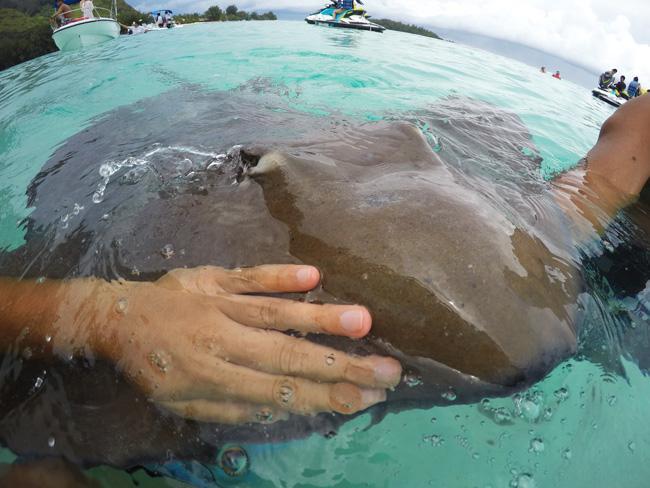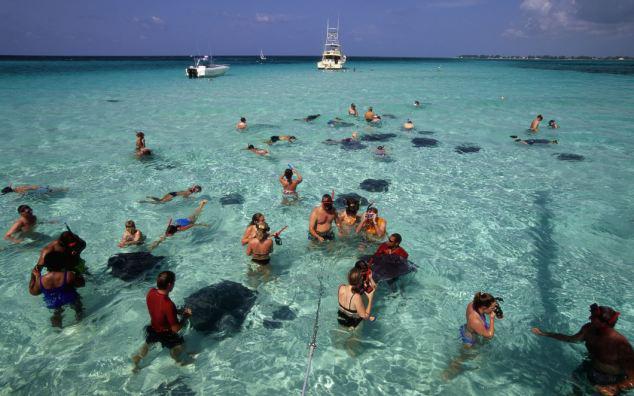The first image is the image on the left, the second image is the image on the right. Examine the images to the left and right. Is the description "At least one person is interacting with a marine animal at the water's surface." accurate? Answer yes or no. Yes. The first image is the image on the left, the second image is the image on the right. Assess this claim about the two images: "There is a close up of human hands petting the stingrays.". Correct or not? Answer yes or no. Yes. 